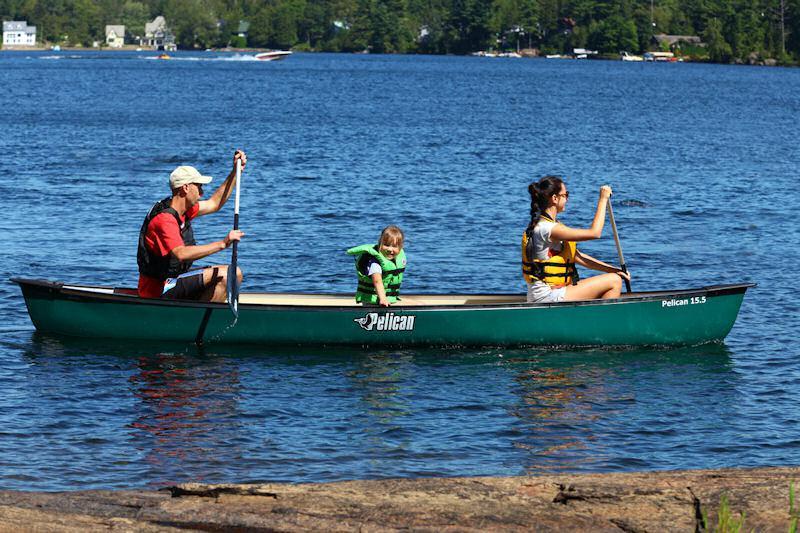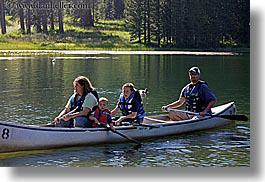The first image is the image on the left, the second image is the image on the right. Analyze the images presented: Is the assertion "The left image shows three people in a lefward-facing horizontal red-orange canoe." valid? Answer yes or no. No. The first image is the image on the left, the second image is the image on the right. Analyze the images presented: Is the assertion "In the red boat in the left image, there are three people." valid? Answer yes or no. No. 